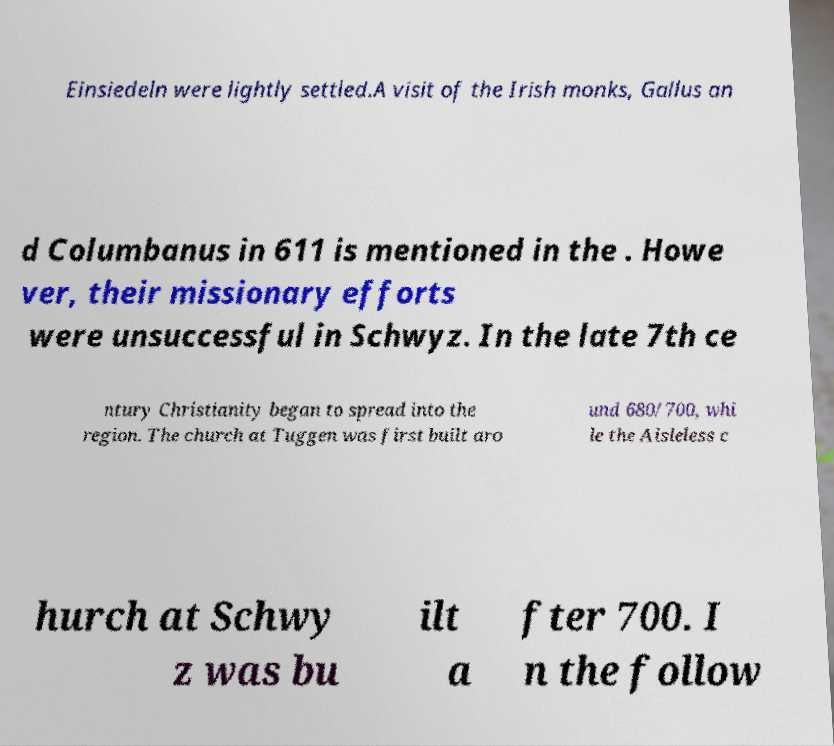Can you read and provide the text displayed in the image?This photo seems to have some interesting text. Can you extract and type it out for me? Einsiedeln were lightly settled.A visit of the Irish monks, Gallus an d Columbanus in 611 is mentioned in the . Howe ver, their missionary efforts were unsuccessful in Schwyz. In the late 7th ce ntury Christianity began to spread into the region. The church at Tuggen was first built aro und 680/700, whi le the Aisleless c hurch at Schwy z was bu ilt a fter 700. I n the follow 